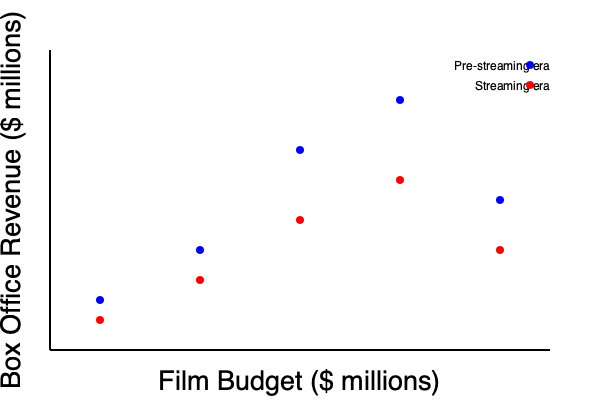Based on the scatter plot comparing film budgets and box office revenues in the pre-streaming and streaming eras, what conclusion can be drawn about the relationship between budget and box office performance in the streaming era? To analyze the relationship between film budgets and box office revenues in the streaming era, we need to follow these steps:

1. Observe the overall trend for both eras:
   - Pre-streaming era (blue dots): As budget increases, box office revenue tends to increase.
   - Streaming era (red dots): A similar trend is visible, but with some key differences.

2. Compare the positions of red dots (streaming era) to blue dots (pre-streaming era):
   - For each budget level, the red dots are generally lower than the corresponding blue dots.
   - This indicates lower box office revenues for similar budget levels in the streaming era.

3. Analyze the slope of the trend:
   - The pre-streaming era shows a steeper slope, suggesting a stronger positive correlation between budget and revenue.
   - The streaming era has a flatter slope, indicating a weaker correlation between budget and revenue.

4. Consider the spread of the data points:
   - The streaming era points show more variation in their vertical positions, suggesting less predictability in box office performance.

5. Interpret the findings in the context of the streaming era:
   - The weaker correlation and lower positioning of red dots suggest that high budgets are less likely to guarantee proportionally high box office revenues in the streaming era.
   - This could be due to increased competition from streaming platforms and changing viewer habits.

Given these observations, we can conclude that in the streaming era, there is a weaker positive correlation between film budgets and box office revenues compared to the pre-streaming era, with generally lower returns on investment for theatrical releases.
Answer: Weaker positive correlation with lower returns 